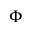Convert formula to latex. <formula><loc_0><loc_0><loc_500><loc_500>\Phi</formula> 